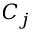<formula> <loc_0><loc_0><loc_500><loc_500>C _ { j }</formula> 